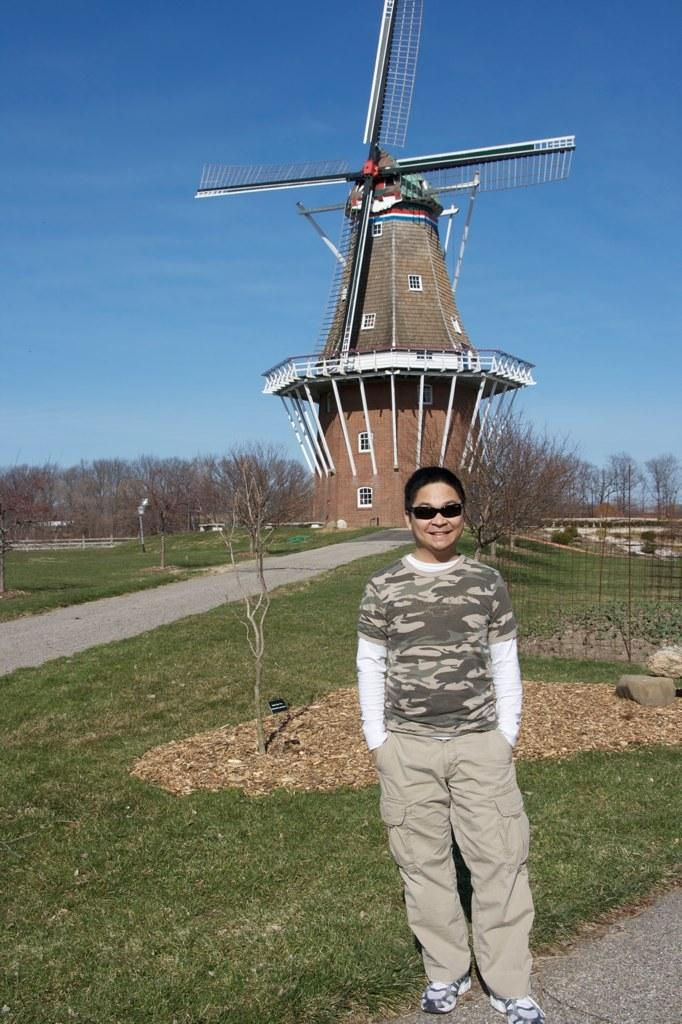What is the main subject of the image? There is a man standing in the image. What can be seen in the background of the image? There is grassland, a path, trees, a windmill, and the sky visible in the background of the image. Can you describe the natural environment in the image? The natural environment includes grassland, trees, and the sky. What type of structure is present in the background of the image? There is a windmill in the background of the image. How does the level of water affect the man in the image? There is no water present in the image, so the level of water does not affect the man. Can you describe the roll of the windmill in the image? There is no roll of the windmill mentioned in the image, as it is a static structure in the background. 